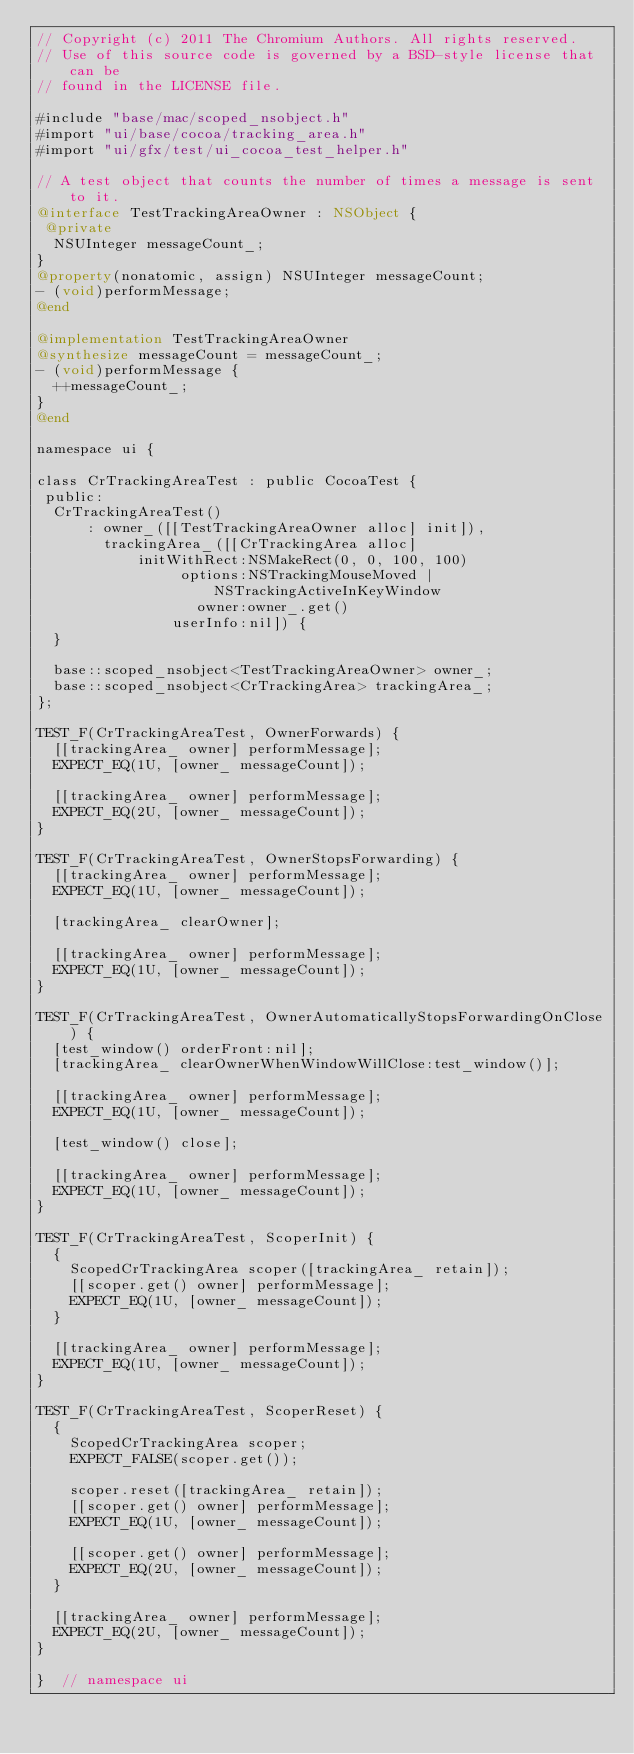Convert code to text. <code><loc_0><loc_0><loc_500><loc_500><_ObjectiveC_>// Copyright (c) 2011 The Chromium Authors. All rights reserved.
// Use of this source code is governed by a BSD-style license that can be
// found in the LICENSE file.

#include "base/mac/scoped_nsobject.h"
#import "ui/base/cocoa/tracking_area.h"
#import "ui/gfx/test/ui_cocoa_test_helper.h"

// A test object that counts the number of times a message is sent to it.
@interface TestTrackingAreaOwner : NSObject {
 @private
  NSUInteger messageCount_;
}
@property(nonatomic, assign) NSUInteger messageCount;
- (void)performMessage;
@end

@implementation TestTrackingAreaOwner
@synthesize messageCount = messageCount_;
- (void)performMessage {
  ++messageCount_;
}
@end

namespace ui {

class CrTrackingAreaTest : public CocoaTest {
 public:
  CrTrackingAreaTest()
      : owner_([[TestTrackingAreaOwner alloc] init]),
        trackingArea_([[CrTrackingArea alloc]
            initWithRect:NSMakeRect(0, 0, 100, 100)
                 options:NSTrackingMouseMoved | NSTrackingActiveInKeyWindow
                   owner:owner_.get()
                userInfo:nil]) {
  }

  base::scoped_nsobject<TestTrackingAreaOwner> owner_;
  base::scoped_nsobject<CrTrackingArea> trackingArea_;
};

TEST_F(CrTrackingAreaTest, OwnerForwards) {
  [[trackingArea_ owner] performMessage];
  EXPECT_EQ(1U, [owner_ messageCount]);

  [[trackingArea_ owner] performMessage];
  EXPECT_EQ(2U, [owner_ messageCount]);
}

TEST_F(CrTrackingAreaTest, OwnerStopsForwarding) {
  [[trackingArea_ owner] performMessage];
  EXPECT_EQ(1U, [owner_ messageCount]);

  [trackingArea_ clearOwner];

  [[trackingArea_ owner] performMessage];
  EXPECT_EQ(1U, [owner_ messageCount]);
}

TEST_F(CrTrackingAreaTest, OwnerAutomaticallyStopsForwardingOnClose) {
  [test_window() orderFront:nil];
  [trackingArea_ clearOwnerWhenWindowWillClose:test_window()];

  [[trackingArea_ owner] performMessage];
  EXPECT_EQ(1U, [owner_ messageCount]);

  [test_window() close];

  [[trackingArea_ owner] performMessage];
  EXPECT_EQ(1U, [owner_ messageCount]);
}

TEST_F(CrTrackingAreaTest, ScoperInit) {
  {
    ScopedCrTrackingArea scoper([trackingArea_ retain]);
    [[scoper.get() owner] performMessage];
    EXPECT_EQ(1U, [owner_ messageCount]);
  }

  [[trackingArea_ owner] performMessage];
  EXPECT_EQ(1U, [owner_ messageCount]);
}

TEST_F(CrTrackingAreaTest, ScoperReset) {
  {
    ScopedCrTrackingArea scoper;
    EXPECT_FALSE(scoper.get());

    scoper.reset([trackingArea_ retain]);
    [[scoper.get() owner] performMessage];
    EXPECT_EQ(1U, [owner_ messageCount]);

    [[scoper.get() owner] performMessage];
    EXPECT_EQ(2U, [owner_ messageCount]);
  }

  [[trackingArea_ owner] performMessage];
  EXPECT_EQ(2U, [owner_ messageCount]);
}

}  // namespace ui
</code> 